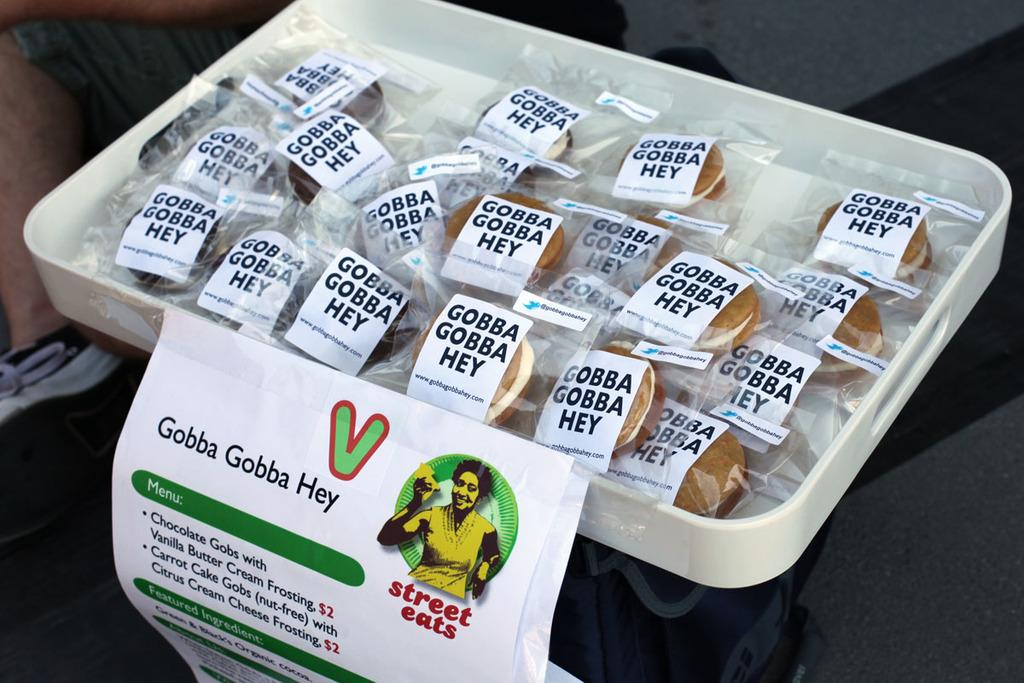What type of food is visible in the image? There are donuts in the image. How are the donuts arranged or presented in the image? The donuts are in a white color tray. What type of appliance is used to prepare the corn in the image? There is no corn or appliance present in the image. 